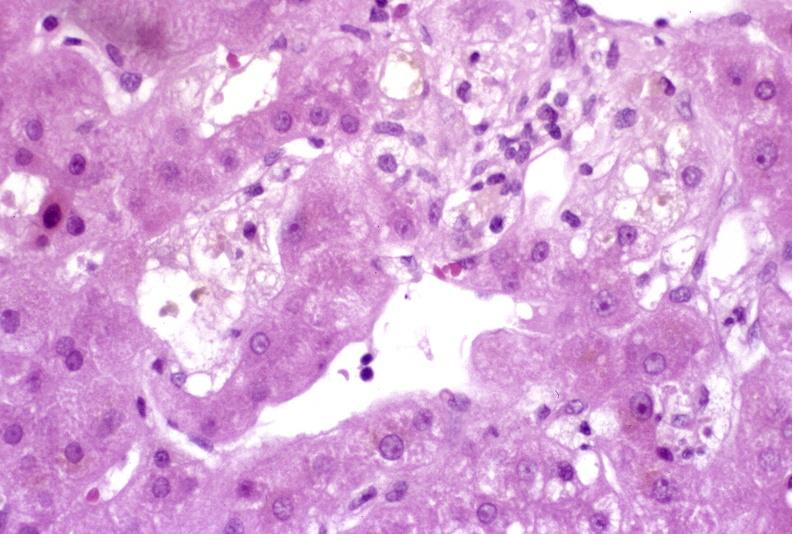s liver present?
Answer the question using a single word or phrase. Yes 